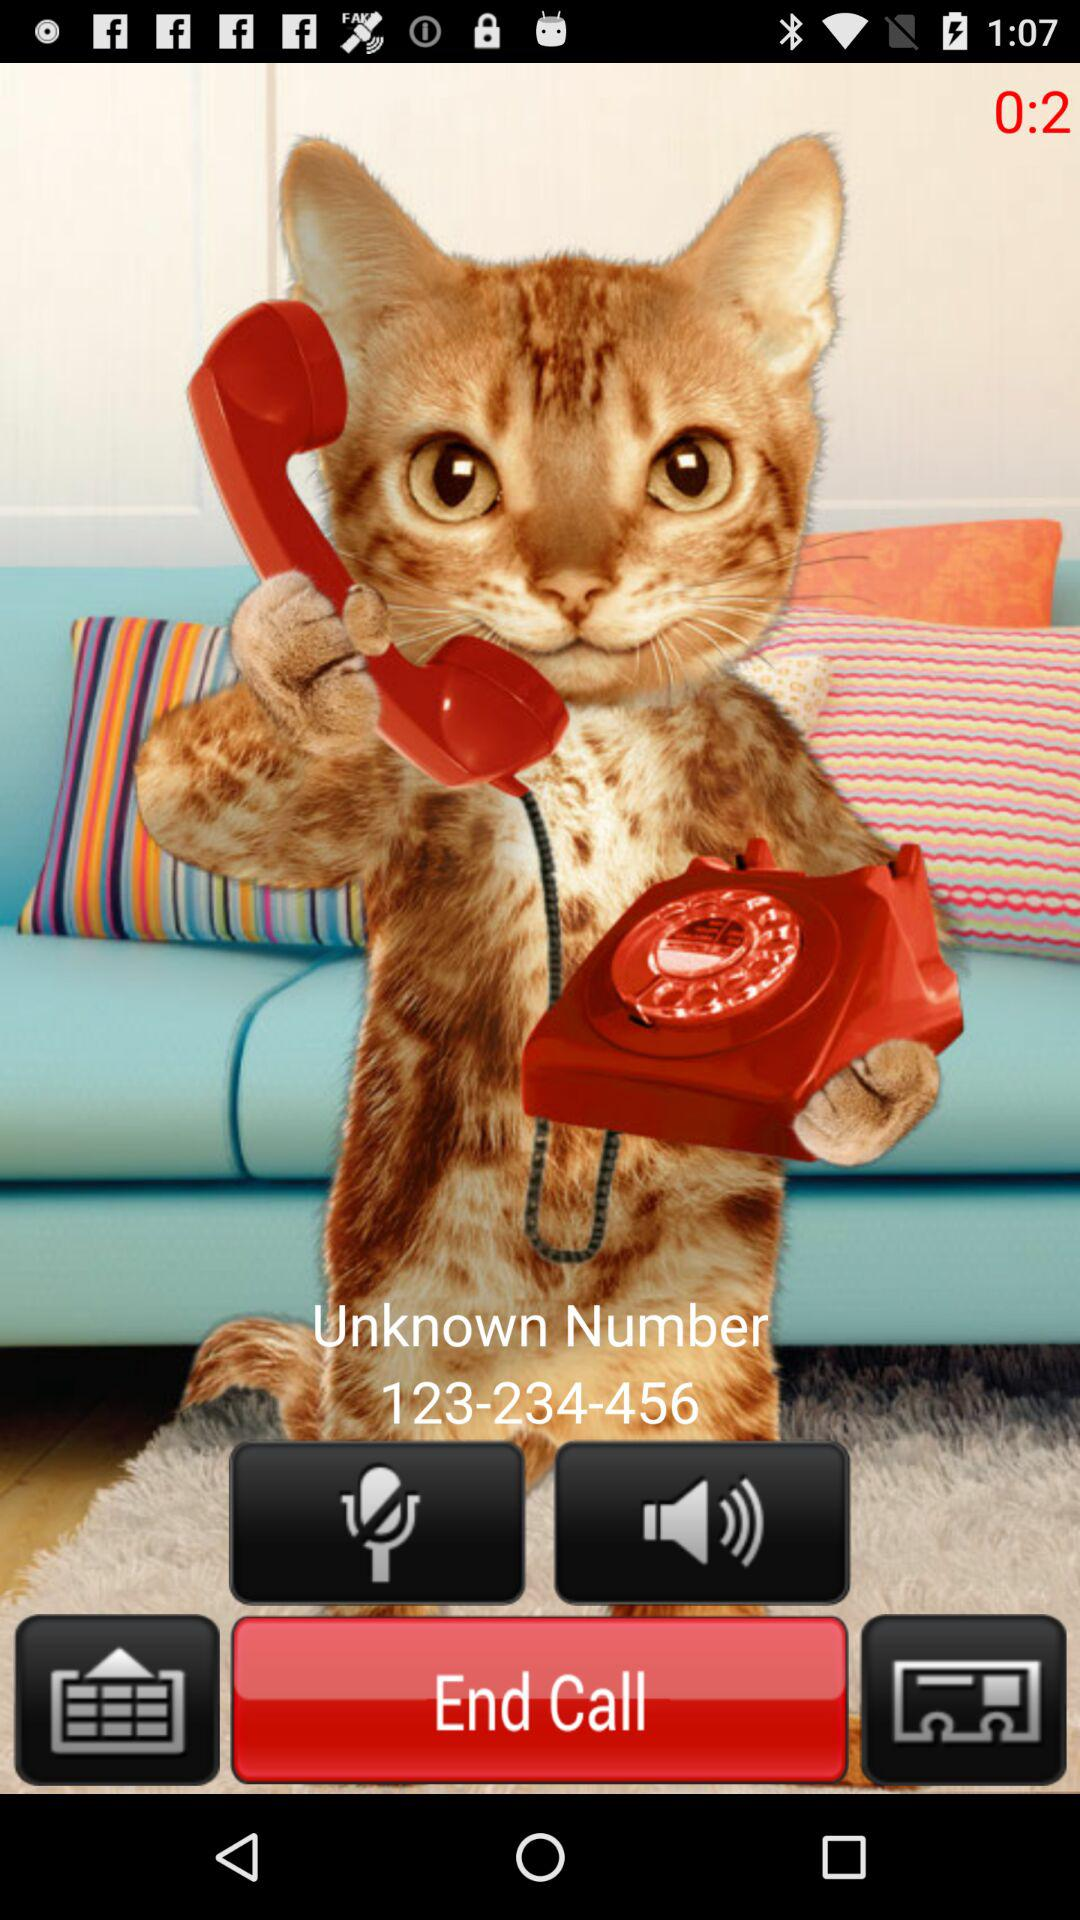What is the phone number? The phone number is 123-234-456. 